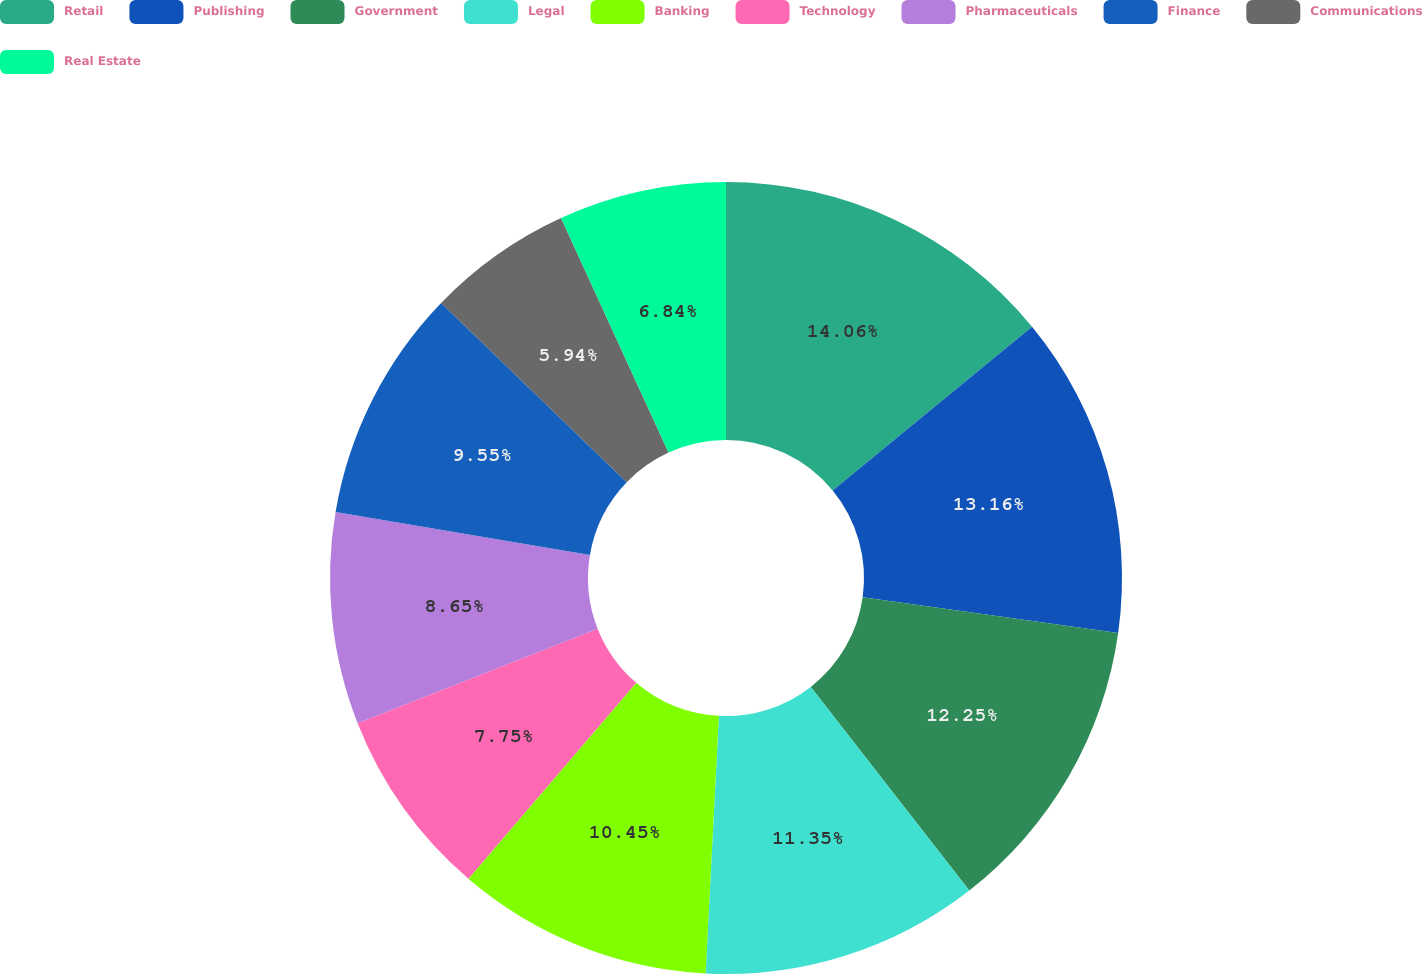Convert chart. <chart><loc_0><loc_0><loc_500><loc_500><pie_chart><fcel>Retail<fcel>Publishing<fcel>Government<fcel>Legal<fcel>Banking<fcel>Technology<fcel>Pharmaceuticals<fcel>Finance<fcel>Communications<fcel>Real Estate<nl><fcel>14.06%<fcel>13.16%<fcel>12.25%<fcel>11.35%<fcel>10.45%<fcel>7.75%<fcel>8.65%<fcel>9.55%<fcel>5.94%<fcel>6.84%<nl></chart> 